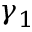Convert formula to latex. <formula><loc_0><loc_0><loc_500><loc_500>\gamma _ { 1 }</formula> 